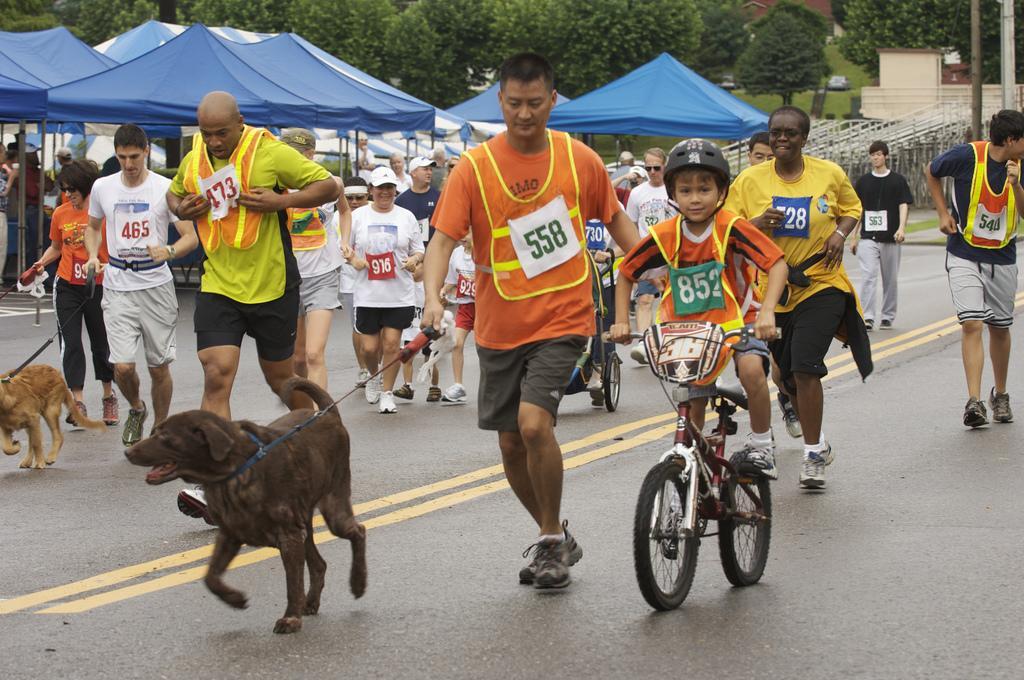Can you describe this image briefly? Here we can see some persons are running on the road. He is on the bicycle and there are dogs. Here we can see umbrellas. There are trees and this is house. There is a pole. 